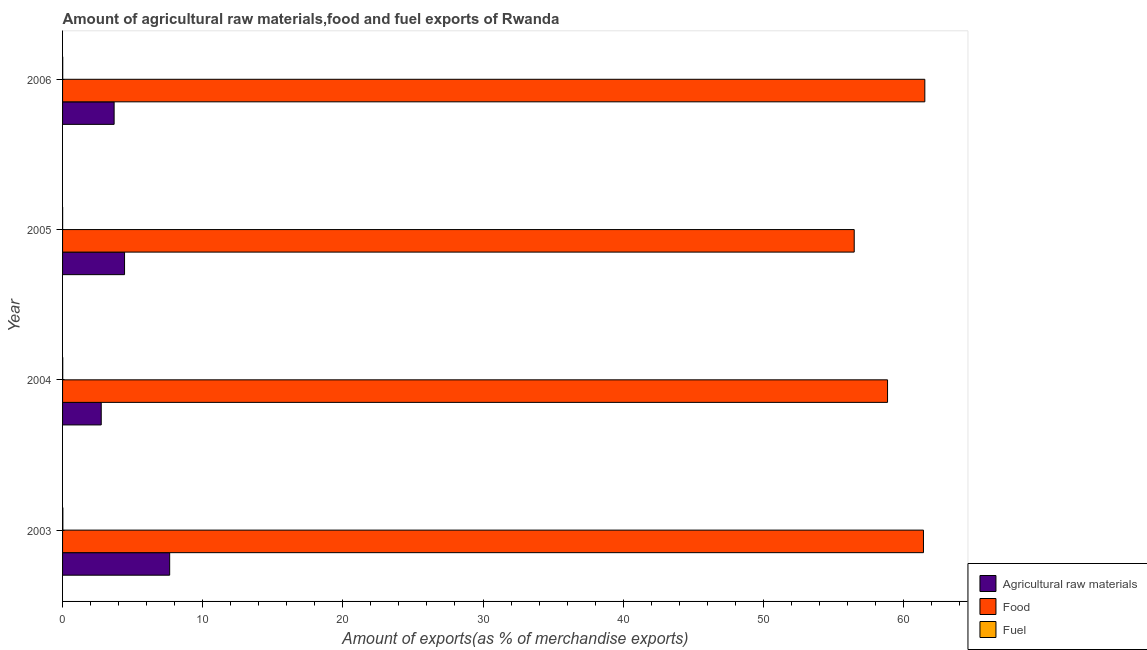How many different coloured bars are there?
Your response must be concise. 3. How many groups of bars are there?
Provide a succinct answer. 4. Are the number of bars per tick equal to the number of legend labels?
Keep it short and to the point. Yes. How many bars are there on the 4th tick from the top?
Your answer should be compact. 3. How many bars are there on the 1st tick from the bottom?
Offer a very short reply. 3. What is the percentage of raw materials exports in 2005?
Your answer should be very brief. 4.42. Across all years, what is the maximum percentage of raw materials exports?
Keep it short and to the point. 7.64. Across all years, what is the minimum percentage of fuel exports?
Offer a very short reply. 0. In which year was the percentage of fuel exports minimum?
Offer a very short reply. 2005. What is the total percentage of raw materials exports in the graph?
Provide a succinct answer. 18.5. What is the difference between the percentage of food exports in 2004 and that in 2006?
Ensure brevity in your answer.  -2.66. What is the difference between the percentage of food exports in 2004 and the percentage of fuel exports in 2005?
Offer a very short reply. 58.86. What is the average percentage of food exports per year?
Your answer should be very brief. 59.58. In the year 2005, what is the difference between the percentage of raw materials exports and percentage of fuel exports?
Your response must be concise. 4.42. In how many years, is the percentage of raw materials exports greater than 8 %?
Your response must be concise. 0. What is the ratio of the percentage of raw materials exports in 2004 to that in 2005?
Offer a very short reply. 0.62. Is the difference between the percentage of raw materials exports in 2004 and 2005 greater than the difference between the percentage of food exports in 2004 and 2005?
Ensure brevity in your answer.  No. What is the difference between the highest and the second highest percentage of raw materials exports?
Keep it short and to the point. 3.22. What is the difference between the highest and the lowest percentage of raw materials exports?
Give a very brief answer. 4.88. What does the 2nd bar from the top in 2003 represents?
Ensure brevity in your answer.  Food. What does the 3rd bar from the bottom in 2005 represents?
Your response must be concise. Fuel. How many bars are there?
Keep it short and to the point. 12. How many years are there in the graph?
Your answer should be very brief. 4. Are the values on the major ticks of X-axis written in scientific E-notation?
Ensure brevity in your answer.  No. Where does the legend appear in the graph?
Your answer should be compact. Bottom right. What is the title of the graph?
Give a very brief answer. Amount of agricultural raw materials,food and fuel exports of Rwanda. What is the label or title of the X-axis?
Offer a very short reply. Amount of exports(as % of merchandise exports). What is the Amount of exports(as % of merchandise exports) of Agricultural raw materials in 2003?
Provide a succinct answer. 7.64. What is the Amount of exports(as % of merchandise exports) in Food in 2003?
Your answer should be very brief. 61.43. What is the Amount of exports(as % of merchandise exports) in Fuel in 2003?
Offer a very short reply. 0.02. What is the Amount of exports(as % of merchandise exports) of Agricultural raw materials in 2004?
Provide a succinct answer. 2.76. What is the Amount of exports(as % of merchandise exports) in Food in 2004?
Give a very brief answer. 58.86. What is the Amount of exports(as % of merchandise exports) of Fuel in 2004?
Offer a terse response. 0.01. What is the Amount of exports(as % of merchandise exports) of Agricultural raw materials in 2005?
Offer a terse response. 4.42. What is the Amount of exports(as % of merchandise exports) of Food in 2005?
Your answer should be very brief. 56.49. What is the Amount of exports(as % of merchandise exports) in Fuel in 2005?
Provide a short and direct response. 0. What is the Amount of exports(as % of merchandise exports) of Agricultural raw materials in 2006?
Your answer should be compact. 3.68. What is the Amount of exports(as % of merchandise exports) in Food in 2006?
Ensure brevity in your answer.  61.53. What is the Amount of exports(as % of merchandise exports) of Fuel in 2006?
Your answer should be very brief. 0.01. Across all years, what is the maximum Amount of exports(as % of merchandise exports) in Agricultural raw materials?
Offer a terse response. 7.64. Across all years, what is the maximum Amount of exports(as % of merchandise exports) in Food?
Offer a terse response. 61.53. Across all years, what is the maximum Amount of exports(as % of merchandise exports) of Fuel?
Your response must be concise. 0.02. Across all years, what is the minimum Amount of exports(as % of merchandise exports) in Agricultural raw materials?
Make the answer very short. 2.76. Across all years, what is the minimum Amount of exports(as % of merchandise exports) of Food?
Make the answer very short. 56.49. Across all years, what is the minimum Amount of exports(as % of merchandise exports) in Fuel?
Provide a short and direct response. 0. What is the total Amount of exports(as % of merchandise exports) of Agricultural raw materials in the graph?
Give a very brief answer. 18.5. What is the total Amount of exports(as % of merchandise exports) in Food in the graph?
Your answer should be very brief. 238.31. What is the total Amount of exports(as % of merchandise exports) of Fuel in the graph?
Your answer should be compact. 0.05. What is the difference between the Amount of exports(as % of merchandise exports) in Agricultural raw materials in 2003 and that in 2004?
Keep it short and to the point. 4.88. What is the difference between the Amount of exports(as % of merchandise exports) of Food in 2003 and that in 2004?
Provide a short and direct response. 2.56. What is the difference between the Amount of exports(as % of merchandise exports) of Fuel in 2003 and that in 2004?
Give a very brief answer. 0.01. What is the difference between the Amount of exports(as % of merchandise exports) in Agricultural raw materials in 2003 and that in 2005?
Offer a very short reply. 3.22. What is the difference between the Amount of exports(as % of merchandise exports) of Food in 2003 and that in 2005?
Provide a succinct answer. 4.94. What is the difference between the Amount of exports(as % of merchandise exports) of Fuel in 2003 and that in 2005?
Your answer should be compact. 0.02. What is the difference between the Amount of exports(as % of merchandise exports) of Agricultural raw materials in 2003 and that in 2006?
Offer a very short reply. 3.96. What is the difference between the Amount of exports(as % of merchandise exports) of Food in 2003 and that in 2006?
Ensure brevity in your answer.  -0.1. What is the difference between the Amount of exports(as % of merchandise exports) in Fuel in 2003 and that in 2006?
Provide a short and direct response. 0.01. What is the difference between the Amount of exports(as % of merchandise exports) in Agricultural raw materials in 2004 and that in 2005?
Offer a very short reply. -1.66. What is the difference between the Amount of exports(as % of merchandise exports) of Food in 2004 and that in 2005?
Keep it short and to the point. 2.38. What is the difference between the Amount of exports(as % of merchandise exports) in Fuel in 2004 and that in 2005?
Keep it short and to the point. 0.01. What is the difference between the Amount of exports(as % of merchandise exports) in Agricultural raw materials in 2004 and that in 2006?
Ensure brevity in your answer.  -0.92. What is the difference between the Amount of exports(as % of merchandise exports) in Food in 2004 and that in 2006?
Your response must be concise. -2.66. What is the difference between the Amount of exports(as % of merchandise exports) in Fuel in 2004 and that in 2006?
Your answer should be compact. 0. What is the difference between the Amount of exports(as % of merchandise exports) in Agricultural raw materials in 2005 and that in 2006?
Your answer should be compact. 0.74. What is the difference between the Amount of exports(as % of merchandise exports) of Food in 2005 and that in 2006?
Ensure brevity in your answer.  -5.04. What is the difference between the Amount of exports(as % of merchandise exports) in Fuel in 2005 and that in 2006?
Make the answer very short. -0.01. What is the difference between the Amount of exports(as % of merchandise exports) of Agricultural raw materials in 2003 and the Amount of exports(as % of merchandise exports) of Food in 2004?
Offer a terse response. -51.22. What is the difference between the Amount of exports(as % of merchandise exports) in Agricultural raw materials in 2003 and the Amount of exports(as % of merchandise exports) in Fuel in 2004?
Your response must be concise. 7.63. What is the difference between the Amount of exports(as % of merchandise exports) of Food in 2003 and the Amount of exports(as % of merchandise exports) of Fuel in 2004?
Provide a succinct answer. 61.42. What is the difference between the Amount of exports(as % of merchandise exports) in Agricultural raw materials in 2003 and the Amount of exports(as % of merchandise exports) in Food in 2005?
Your answer should be compact. -48.84. What is the difference between the Amount of exports(as % of merchandise exports) in Agricultural raw materials in 2003 and the Amount of exports(as % of merchandise exports) in Fuel in 2005?
Your response must be concise. 7.64. What is the difference between the Amount of exports(as % of merchandise exports) in Food in 2003 and the Amount of exports(as % of merchandise exports) in Fuel in 2005?
Provide a short and direct response. 61.42. What is the difference between the Amount of exports(as % of merchandise exports) in Agricultural raw materials in 2003 and the Amount of exports(as % of merchandise exports) in Food in 2006?
Offer a very short reply. -53.88. What is the difference between the Amount of exports(as % of merchandise exports) of Agricultural raw materials in 2003 and the Amount of exports(as % of merchandise exports) of Fuel in 2006?
Keep it short and to the point. 7.63. What is the difference between the Amount of exports(as % of merchandise exports) in Food in 2003 and the Amount of exports(as % of merchandise exports) in Fuel in 2006?
Your response must be concise. 61.42. What is the difference between the Amount of exports(as % of merchandise exports) of Agricultural raw materials in 2004 and the Amount of exports(as % of merchandise exports) of Food in 2005?
Offer a very short reply. -53.73. What is the difference between the Amount of exports(as % of merchandise exports) in Agricultural raw materials in 2004 and the Amount of exports(as % of merchandise exports) in Fuel in 2005?
Give a very brief answer. 2.75. What is the difference between the Amount of exports(as % of merchandise exports) of Food in 2004 and the Amount of exports(as % of merchandise exports) of Fuel in 2005?
Your response must be concise. 58.86. What is the difference between the Amount of exports(as % of merchandise exports) of Agricultural raw materials in 2004 and the Amount of exports(as % of merchandise exports) of Food in 2006?
Ensure brevity in your answer.  -58.77. What is the difference between the Amount of exports(as % of merchandise exports) in Agricultural raw materials in 2004 and the Amount of exports(as % of merchandise exports) in Fuel in 2006?
Your response must be concise. 2.75. What is the difference between the Amount of exports(as % of merchandise exports) of Food in 2004 and the Amount of exports(as % of merchandise exports) of Fuel in 2006?
Offer a terse response. 58.85. What is the difference between the Amount of exports(as % of merchandise exports) in Agricultural raw materials in 2005 and the Amount of exports(as % of merchandise exports) in Food in 2006?
Offer a terse response. -57.1. What is the difference between the Amount of exports(as % of merchandise exports) of Agricultural raw materials in 2005 and the Amount of exports(as % of merchandise exports) of Fuel in 2006?
Your answer should be compact. 4.41. What is the difference between the Amount of exports(as % of merchandise exports) in Food in 2005 and the Amount of exports(as % of merchandise exports) in Fuel in 2006?
Make the answer very short. 56.48. What is the average Amount of exports(as % of merchandise exports) of Agricultural raw materials per year?
Your answer should be very brief. 4.63. What is the average Amount of exports(as % of merchandise exports) in Food per year?
Give a very brief answer. 59.58. What is the average Amount of exports(as % of merchandise exports) in Fuel per year?
Provide a succinct answer. 0.01. In the year 2003, what is the difference between the Amount of exports(as % of merchandise exports) of Agricultural raw materials and Amount of exports(as % of merchandise exports) of Food?
Make the answer very short. -53.79. In the year 2003, what is the difference between the Amount of exports(as % of merchandise exports) in Agricultural raw materials and Amount of exports(as % of merchandise exports) in Fuel?
Your response must be concise. 7.62. In the year 2003, what is the difference between the Amount of exports(as % of merchandise exports) of Food and Amount of exports(as % of merchandise exports) of Fuel?
Provide a succinct answer. 61.41. In the year 2004, what is the difference between the Amount of exports(as % of merchandise exports) of Agricultural raw materials and Amount of exports(as % of merchandise exports) of Food?
Your response must be concise. -56.11. In the year 2004, what is the difference between the Amount of exports(as % of merchandise exports) of Agricultural raw materials and Amount of exports(as % of merchandise exports) of Fuel?
Ensure brevity in your answer.  2.75. In the year 2004, what is the difference between the Amount of exports(as % of merchandise exports) of Food and Amount of exports(as % of merchandise exports) of Fuel?
Your response must be concise. 58.85. In the year 2005, what is the difference between the Amount of exports(as % of merchandise exports) of Agricultural raw materials and Amount of exports(as % of merchandise exports) of Food?
Provide a succinct answer. -52.06. In the year 2005, what is the difference between the Amount of exports(as % of merchandise exports) in Agricultural raw materials and Amount of exports(as % of merchandise exports) in Fuel?
Your answer should be compact. 4.42. In the year 2005, what is the difference between the Amount of exports(as % of merchandise exports) of Food and Amount of exports(as % of merchandise exports) of Fuel?
Provide a short and direct response. 56.48. In the year 2006, what is the difference between the Amount of exports(as % of merchandise exports) in Agricultural raw materials and Amount of exports(as % of merchandise exports) in Food?
Your response must be concise. -57.85. In the year 2006, what is the difference between the Amount of exports(as % of merchandise exports) of Agricultural raw materials and Amount of exports(as % of merchandise exports) of Fuel?
Offer a very short reply. 3.67. In the year 2006, what is the difference between the Amount of exports(as % of merchandise exports) in Food and Amount of exports(as % of merchandise exports) in Fuel?
Keep it short and to the point. 61.51. What is the ratio of the Amount of exports(as % of merchandise exports) in Agricultural raw materials in 2003 to that in 2004?
Provide a succinct answer. 2.77. What is the ratio of the Amount of exports(as % of merchandise exports) in Food in 2003 to that in 2004?
Keep it short and to the point. 1.04. What is the ratio of the Amount of exports(as % of merchandise exports) of Fuel in 2003 to that in 2004?
Provide a succinct answer. 1.68. What is the ratio of the Amount of exports(as % of merchandise exports) in Agricultural raw materials in 2003 to that in 2005?
Your answer should be compact. 1.73. What is the ratio of the Amount of exports(as % of merchandise exports) of Food in 2003 to that in 2005?
Give a very brief answer. 1.09. What is the ratio of the Amount of exports(as % of merchandise exports) of Fuel in 2003 to that in 2005?
Give a very brief answer. 5.35. What is the ratio of the Amount of exports(as % of merchandise exports) of Agricultural raw materials in 2003 to that in 2006?
Ensure brevity in your answer.  2.08. What is the ratio of the Amount of exports(as % of merchandise exports) of Food in 2003 to that in 2006?
Your answer should be very brief. 1. What is the ratio of the Amount of exports(as % of merchandise exports) in Fuel in 2003 to that in 2006?
Keep it short and to the point. 1.91. What is the ratio of the Amount of exports(as % of merchandise exports) of Agricultural raw materials in 2004 to that in 2005?
Offer a terse response. 0.62. What is the ratio of the Amount of exports(as % of merchandise exports) in Food in 2004 to that in 2005?
Offer a very short reply. 1.04. What is the ratio of the Amount of exports(as % of merchandise exports) of Fuel in 2004 to that in 2005?
Provide a short and direct response. 3.19. What is the ratio of the Amount of exports(as % of merchandise exports) in Agricultural raw materials in 2004 to that in 2006?
Provide a succinct answer. 0.75. What is the ratio of the Amount of exports(as % of merchandise exports) of Food in 2004 to that in 2006?
Your answer should be very brief. 0.96. What is the ratio of the Amount of exports(as % of merchandise exports) of Fuel in 2004 to that in 2006?
Keep it short and to the point. 1.14. What is the ratio of the Amount of exports(as % of merchandise exports) in Agricultural raw materials in 2005 to that in 2006?
Provide a succinct answer. 1.2. What is the ratio of the Amount of exports(as % of merchandise exports) in Food in 2005 to that in 2006?
Offer a very short reply. 0.92. What is the ratio of the Amount of exports(as % of merchandise exports) in Fuel in 2005 to that in 2006?
Give a very brief answer. 0.36. What is the difference between the highest and the second highest Amount of exports(as % of merchandise exports) in Agricultural raw materials?
Make the answer very short. 3.22. What is the difference between the highest and the second highest Amount of exports(as % of merchandise exports) in Food?
Your answer should be compact. 0.1. What is the difference between the highest and the second highest Amount of exports(as % of merchandise exports) in Fuel?
Your answer should be very brief. 0.01. What is the difference between the highest and the lowest Amount of exports(as % of merchandise exports) in Agricultural raw materials?
Your answer should be compact. 4.88. What is the difference between the highest and the lowest Amount of exports(as % of merchandise exports) in Food?
Your response must be concise. 5.04. What is the difference between the highest and the lowest Amount of exports(as % of merchandise exports) in Fuel?
Keep it short and to the point. 0.02. 